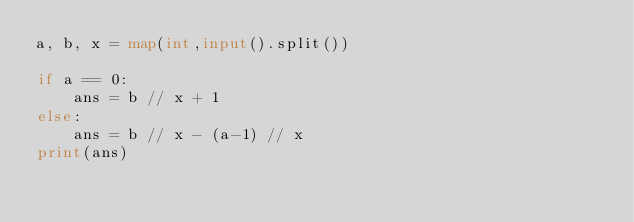<code> <loc_0><loc_0><loc_500><loc_500><_Python_>a, b, x = map(int,input().split())

if a == 0:
    ans = b // x + 1
else:
    ans = b // x - (a-1) // x
print(ans)</code> 